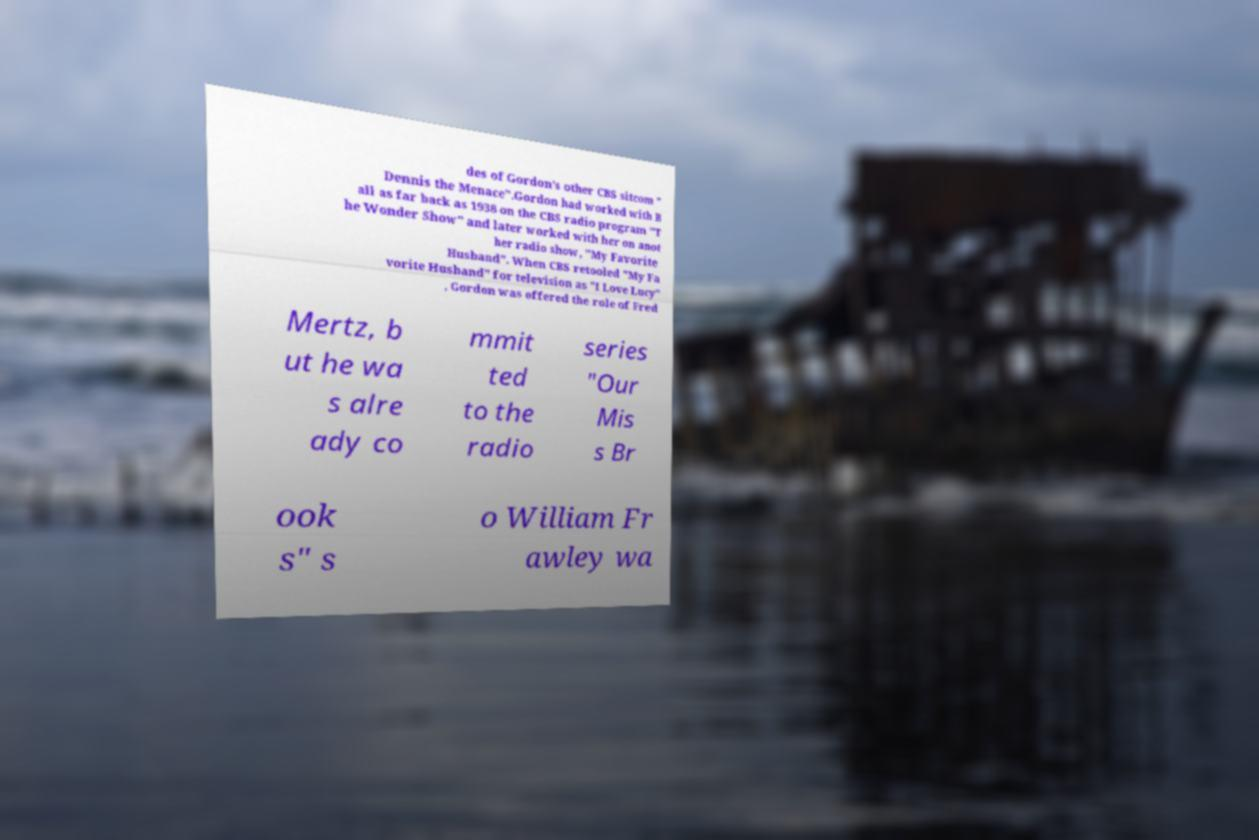What messages or text are displayed in this image? I need them in a readable, typed format. des of Gordon's other CBS sitcom " Dennis the Menace".Gordon had worked with B all as far back as 1938 on the CBS radio program "T he Wonder Show" and later worked with her on anot her radio show, "My Favorite Husband". When CBS retooled "My Fa vorite Husband" for television as "I Love Lucy" , Gordon was offered the role of Fred Mertz, b ut he wa s alre ady co mmit ted to the radio series "Our Mis s Br ook s" s o William Fr awley wa 